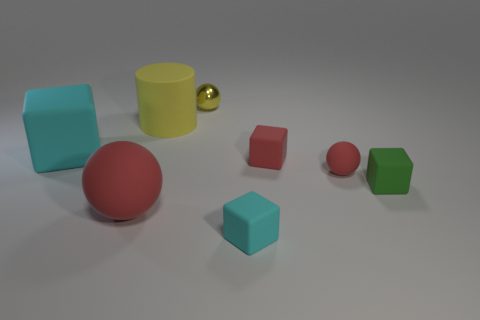The large matte thing that is to the right of the large rubber block and in front of the big yellow rubber thing has what shape?
Your answer should be compact. Sphere. There is a small block behind the red matte sphere that is to the right of the yellow cylinder; what is its material?
Your answer should be compact. Rubber. Are there more tiny cyan things than big brown metal cylinders?
Give a very brief answer. Yes. Is the color of the big matte sphere the same as the matte cylinder?
Your response must be concise. No. What is the material of the yellow thing that is the same size as the red rubber block?
Your response must be concise. Metal. Does the red cube have the same material as the large ball?
Give a very brief answer. Yes. What number of yellow objects are the same material as the tiny cyan block?
Give a very brief answer. 1. What number of objects are either things that are behind the big rubber cylinder or yellow spheres on the right side of the yellow cylinder?
Ensure brevity in your answer.  1. Is the number of tiny rubber things that are on the right side of the red matte cube greater than the number of big red objects in front of the tiny cyan rubber thing?
Give a very brief answer. Yes. There is a block that is in front of the green object; what is its color?
Ensure brevity in your answer.  Cyan. 